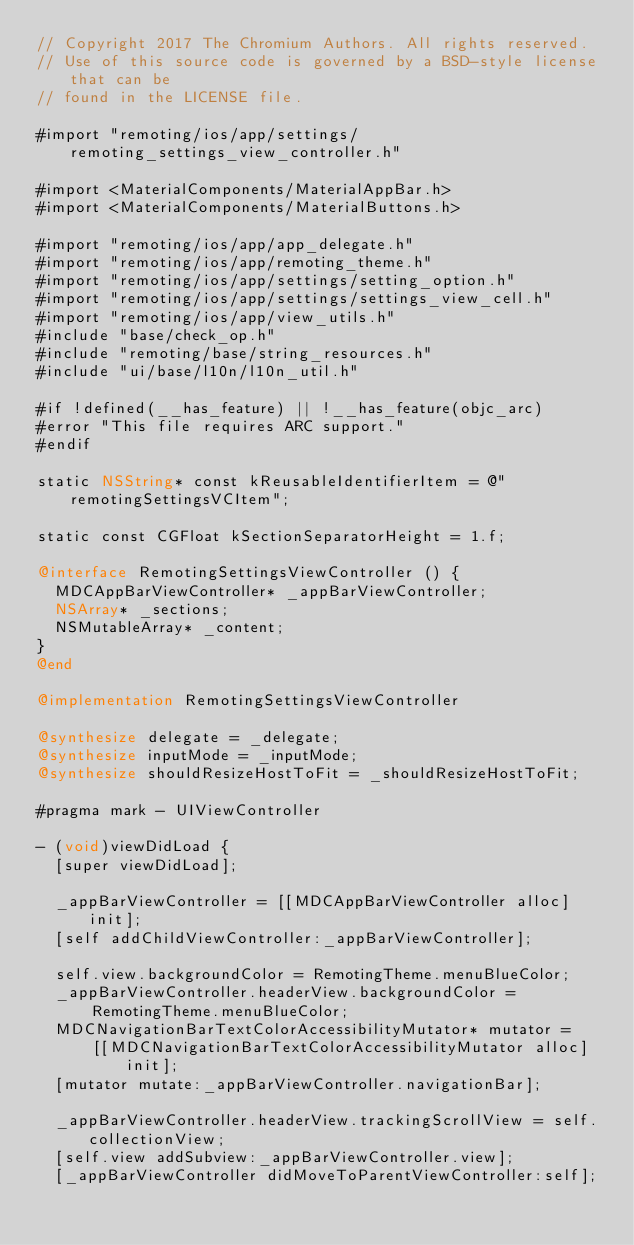Convert code to text. <code><loc_0><loc_0><loc_500><loc_500><_ObjectiveC_>// Copyright 2017 The Chromium Authors. All rights reserved.
// Use of this source code is governed by a BSD-style license that can be
// found in the LICENSE file.

#import "remoting/ios/app/settings/remoting_settings_view_controller.h"

#import <MaterialComponents/MaterialAppBar.h>
#import <MaterialComponents/MaterialButtons.h>

#import "remoting/ios/app/app_delegate.h"
#import "remoting/ios/app/remoting_theme.h"
#import "remoting/ios/app/settings/setting_option.h"
#import "remoting/ios/app/settings/settings_view_cell.h"
#import "remoting/ios/app/view_utils.h"
#include "base/check_op.h"
#include "remoting/base/string_resources.h"
#include "ui/base/l10n/l10n_util.h"

#if !defined(__has_feature) || !__has_feature(objc_arc)
#error "This file requires ARC support."
#endif

static NSString* const kReusableIdentifierItem = @"remotingSettingsVCItem";

static const CGFloat kSectionSeparatorHeight = 1.f;

@interface RemotingSettingsViewController () {
  MDCAppBarViewController* _appBarViewController;
  NSArray* _sections;
  NSMutableArray* _content;
}
@end

@implementation RemotingSettingsViewController

@synthesize delegate = _delegate;
@synthesize inputMode = _inputMode;
@synthesize shouldResizeHostToFit = _shouldResizeHostToFit;

#pragma mark - UIViewController

- (void)viewDidLoad {
  [super viewDidLoad];

  _appBarViewController = [[MDCAppBarViewController alloc] init];
  [self addChildViewController:_appBarViewController];

  self.view.backgroundColor = RemotingTheme.menuBlueColor;
  _appBarViewController.headerView.backgroundColor =
      RemotingTheme.menuBlueColor;
  MDCNavigationBarTextColorAccessibilityMutator* mutator =
      [[MDCNavigationBarTextColorAccessibilityMutator alloc] init];
  [mutator mutate:_appBarViewController.navigationBar];

  _appBarViewController.headerView.trackingScrollView = self.collectionView;
  [self.view addSubview:_appBarViewController.view];
  [_appBarViewController didMoveToParentViewController:self];
</code> 